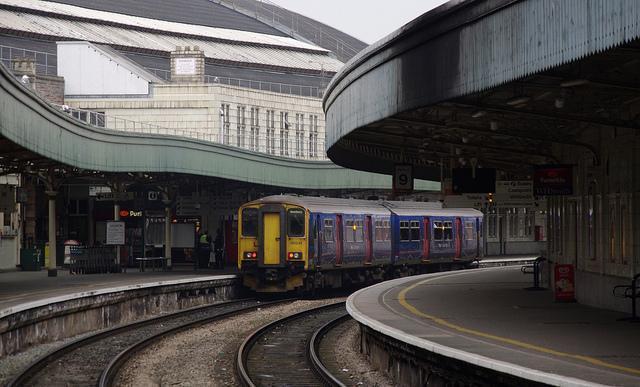Why is the yellow line painted on the ground?
Answer the question by selecting the correct answer among the 4 following choices and explain your choice with a short sentence. The answer should be formatted with the following format: `Answer: choice
Rationale: rationale.`
Options: Decoration, safety, vandalism, amusement. Answer: safety.
Rationale: The line is for safety. 